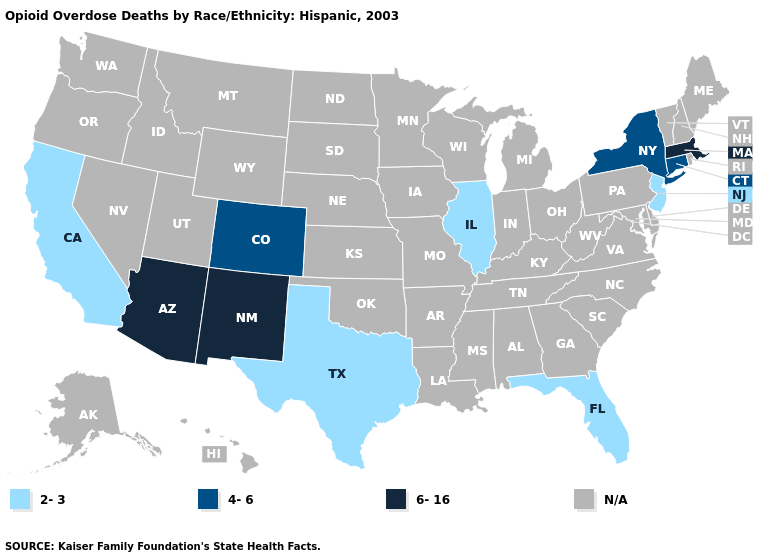Name the states that have a value in the range 2-3?
Give a very brief answer. California, Florida, Illinois, New Jersey, Texas. Name the states that have a value in the range 2-3?
Short answer required. California, Florida, Illinois, New Jersey, Texas. Name the states that have a value in the range 2-3?
Give a very brief answer. California, Florida, Illinois, New Jersey, Texas. Is the legend a continuous bar?
Write a very short answer. No. Among the states that border New York , does Massachusetts have the highest value?
Short answer required. Yes. What is the value of Kentucky?
Give a very brief answer. N/A. Name the states that have a value in the range 4-6?
Keep it brief. Colorado, Connecticut, New York. Name the states that have a value in the range 4-6?
Be succinct. Colorado, Connecticut, New York. What is the highest value in the USA?
Short answer required. 6-16. What is the lowest value in the USA?
Keep it brief. 2-3. 